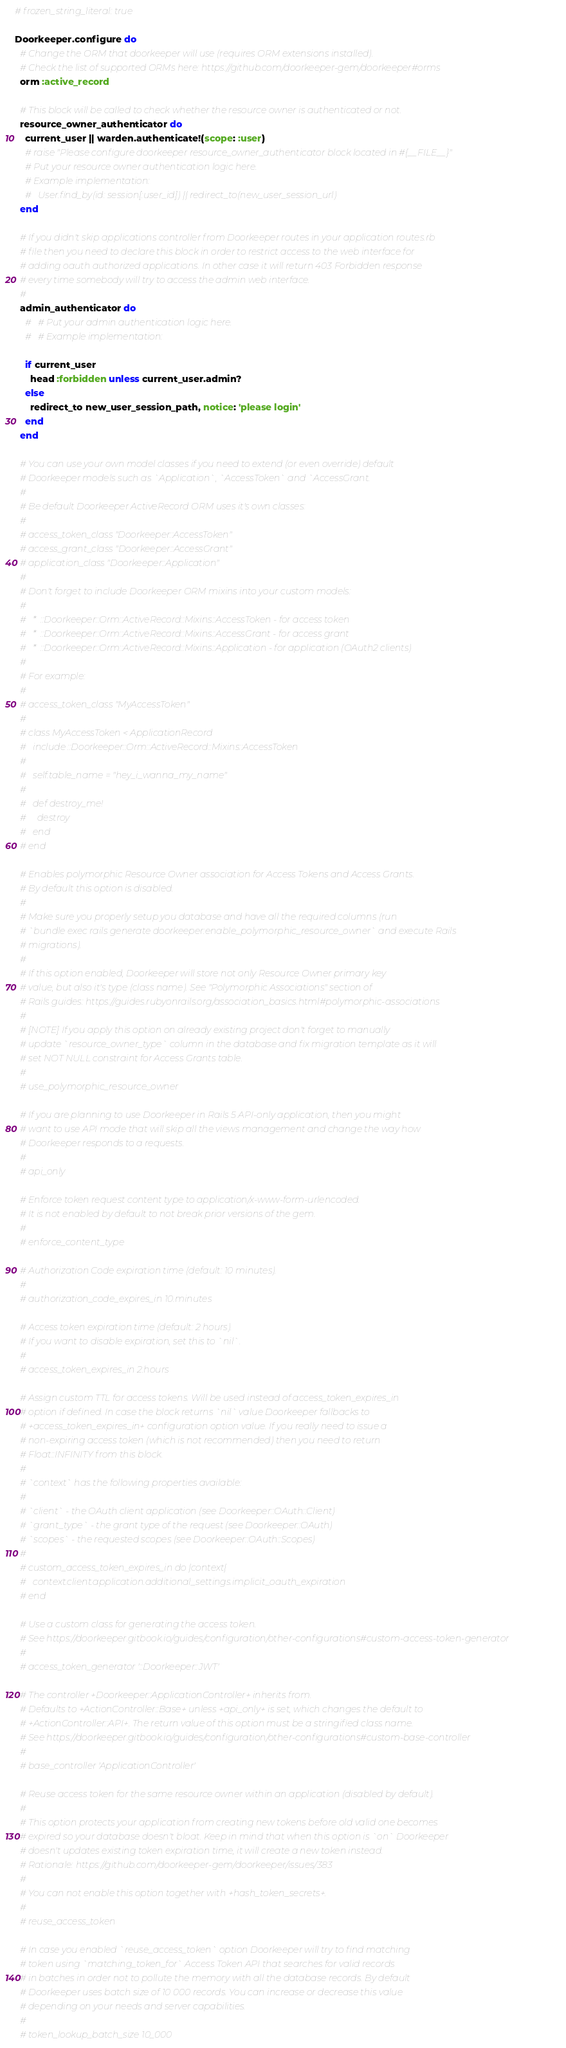Convert code to text. <code><loc_0><loc_0><loc_500><loc_500><_Ruby_># frozen_string_literal: true

Doorkeeper.configure do
  # Change the ORM that doorkeeper will use (requires ORM extensions installed).
  # Check the list of supported ORMs here: https://github.com/doorkeeper-gem/doorkeeper#orms
  orm :active_record

  # This block will be called to check whether the resource owner is authenticated or not.
  resource_owner_authenticator do
    current_user || warden.authenticate!(scope: :user)
    # raise "Please configure doorkeeper resource_owner_authenticator block located in #{__FILE__}"
    # Put your resource owner authentication logic here.
    # Example implementation:
    #   User.find_by(id: session[:user_id]) || redirect_to(new_user_session_url)
  end

  # If you didn't skip applications controller from Doorkeeper routes in your application routes.rb
  # file then you need to declare this block in order to restrict access to the web interface for
  # adding oauth authorized applications. In other case it will return 403 Forbidden response
  # every time somebody will try to access the admin web interface.
  #
  admin_authenticator do
    #   # Put your admin authentication logic here.
    #   # Example implementation:

    if current_user
      head :forbidden unless current_user.admin?
    else
      redirect_to new_user_session_path, notice: 'please login'
    end
  end

  # You can use your own model classes if you need to extend (or even override) default
  # Doorkeeper models such as `Application`, `AccessToken` and `AccessGrant.
  #
  # Be default Doorkeeper ActiveRecord ORM uses it's own classes:
  #
  # access_token_class "Doorkeeper::AccessToken"
  # access_grant_class "Doorkeeper::AccessGrant"
  # application_class "Doorkeeper::Application"
  #
  # Don't forget to include Doorkeeper ORM mixins into your custom models:
  #
  #   *  ::Doorkeeper::Orm::ActiveRecord::Mixins::AccessToken - for access token
  #   *  ::Doorkeeper::Orm::ActiveRecord::Mixins::AccessGrant - for access grant
  #   *  ::Doorkeeper::Orm::ActiveRecord::Mixins::Application - for application (OAuth2 clients)
  #
  # For example:
  #
  # access_token_class "MyAccessToken"
  #
  # class MyAccessToken < ApplicationRecord
  #   include ::Doorkeeper::Orm::ActiveRecord::Mixins::AccessToken
  #
  #   self.table_name = "hey_i_wanna_my_name"
  #
  #   def destroy_me!
  #     destroy
  #   end
  # end

  # Enables polymorphic Resource Owner association for Access Tokens and Access Grants.
  # By default this option is disabled.
  #
  # Make sure you properly setup you database and have all the required columns (run
  # `bundle exec rails generate doorkeeper:enable_polymorphic_resource_owner` and execute Rails
  # migrations).
  #
  # If this option enabled, Doorkeeper will store not only Resource Owner primary key
  # value, but also it's type (class name). See "Polymorphic Associations" section of
  # Rails guides: https://guides.rubyonrails.org/association_basics.html#polymorphic-associations
  #
  # [NOTE] If you apply this option on already existing project don't forget to manually
  # update `resource_owner_type` column in the database and fix migration template as it will
  # set NOT NULL constraint for Access Grants table.
  #
  # use_polymorphic_resource_owner

  # If you are planning to use Doorkeeper in Rails 5 API-only application, then you might
  # want to use API mode that will skip all the views management and change the way how
  # Doorkeeper responds to a requests.
  #
  # api_only

  # Enforce token request content type to application/x-www-form-urlencoded.
  # It is not enabled by default to not break prior versions of the gem.
  #
  # enforce_content_type

  # Authorization Code expiration time (default: 10 minutes).
  #
  # authorization_code_expires_in 10.minutes

  # Access token expiration time (default: 2 hours).
  # If you want to disable expiration, set this to `nil`.
  #
  # access_token_expires_in 2.hours

  # Assign custom TTL for access tokens. Will be used instead of access_token_expires_in
  # option if defined. In case the block returns `nil` value Doorkeeper fallbacks to
  # +access_token_expires_in+ configuration option value. If you really need to issue a
  # non-expiring access token (which is not recommended) then you need to return
  # Float::INFINITY from this block.
  #
  # `context` has the following properties available:
  #
  # `client` - the OAuth client application (see Doorkeeper::OAuth::Client)
  # `grant_type` - the grant type of the request (see Doorkeeper::OAuth)
  # `scopes` - the requested scopes (see Doorkeeper::OAuth::Scopes)
  #
  # custom_access_token_expires_in do |context|
  #   context.client.application.additional_settings.implicit_oauth_expiration
  # end

  # Use a custom class for generating the access token.
  # See https://doorkeeper.gitbook.io/guides/configuration/other-configurations#custom-access-token-generator
  #
  # access_token_generator '::Doorkeeper::JWT'

  # The controller +Doorkeeper::ApplicationController+ inherits from.
  # Defaults to +ActionController::Base+ unless +api_only+ is set, which changes the default to
  # +ActionController::API+. The return value of this option must be a stringified class name.
  # See https://doorkeeper.gitbook.io/guides/configuration/other-configurations#custom-base-controller
  #
  # base_controller 'ApplicationController'

  # Reuse access token for the same resource owner within an application (disabled by default).
  #
  # This option protects your application from creating new tokens before old valid one becomes
  # expired so your database doesn't bloat. Keep in mind that when this option is `on` Doorkeeper
  # doesn't updates existing token expiration time, it will create a new token instead.
  # Rationale: https://github.com/doorkeeper-gem/doorkeeper/issues/383
  #
  # You can not enable this option together with +hash_token_secrets+.
  #
  # reuse_access_token

  # In case you enabled `reuse_access_token` option Doorkeeper will try to find matching
  # token using `matching_token_for` Access Token API that searches for valid records
  # in batches in order not to pollute the memory with all the database records. By default
  # Doorkeeper uses batch size of 10 000 records. You can increase or decrease this value
  # depending on your needs and server capabilities.
  #
  # token_lookup_batch_size 10_000
</code> 